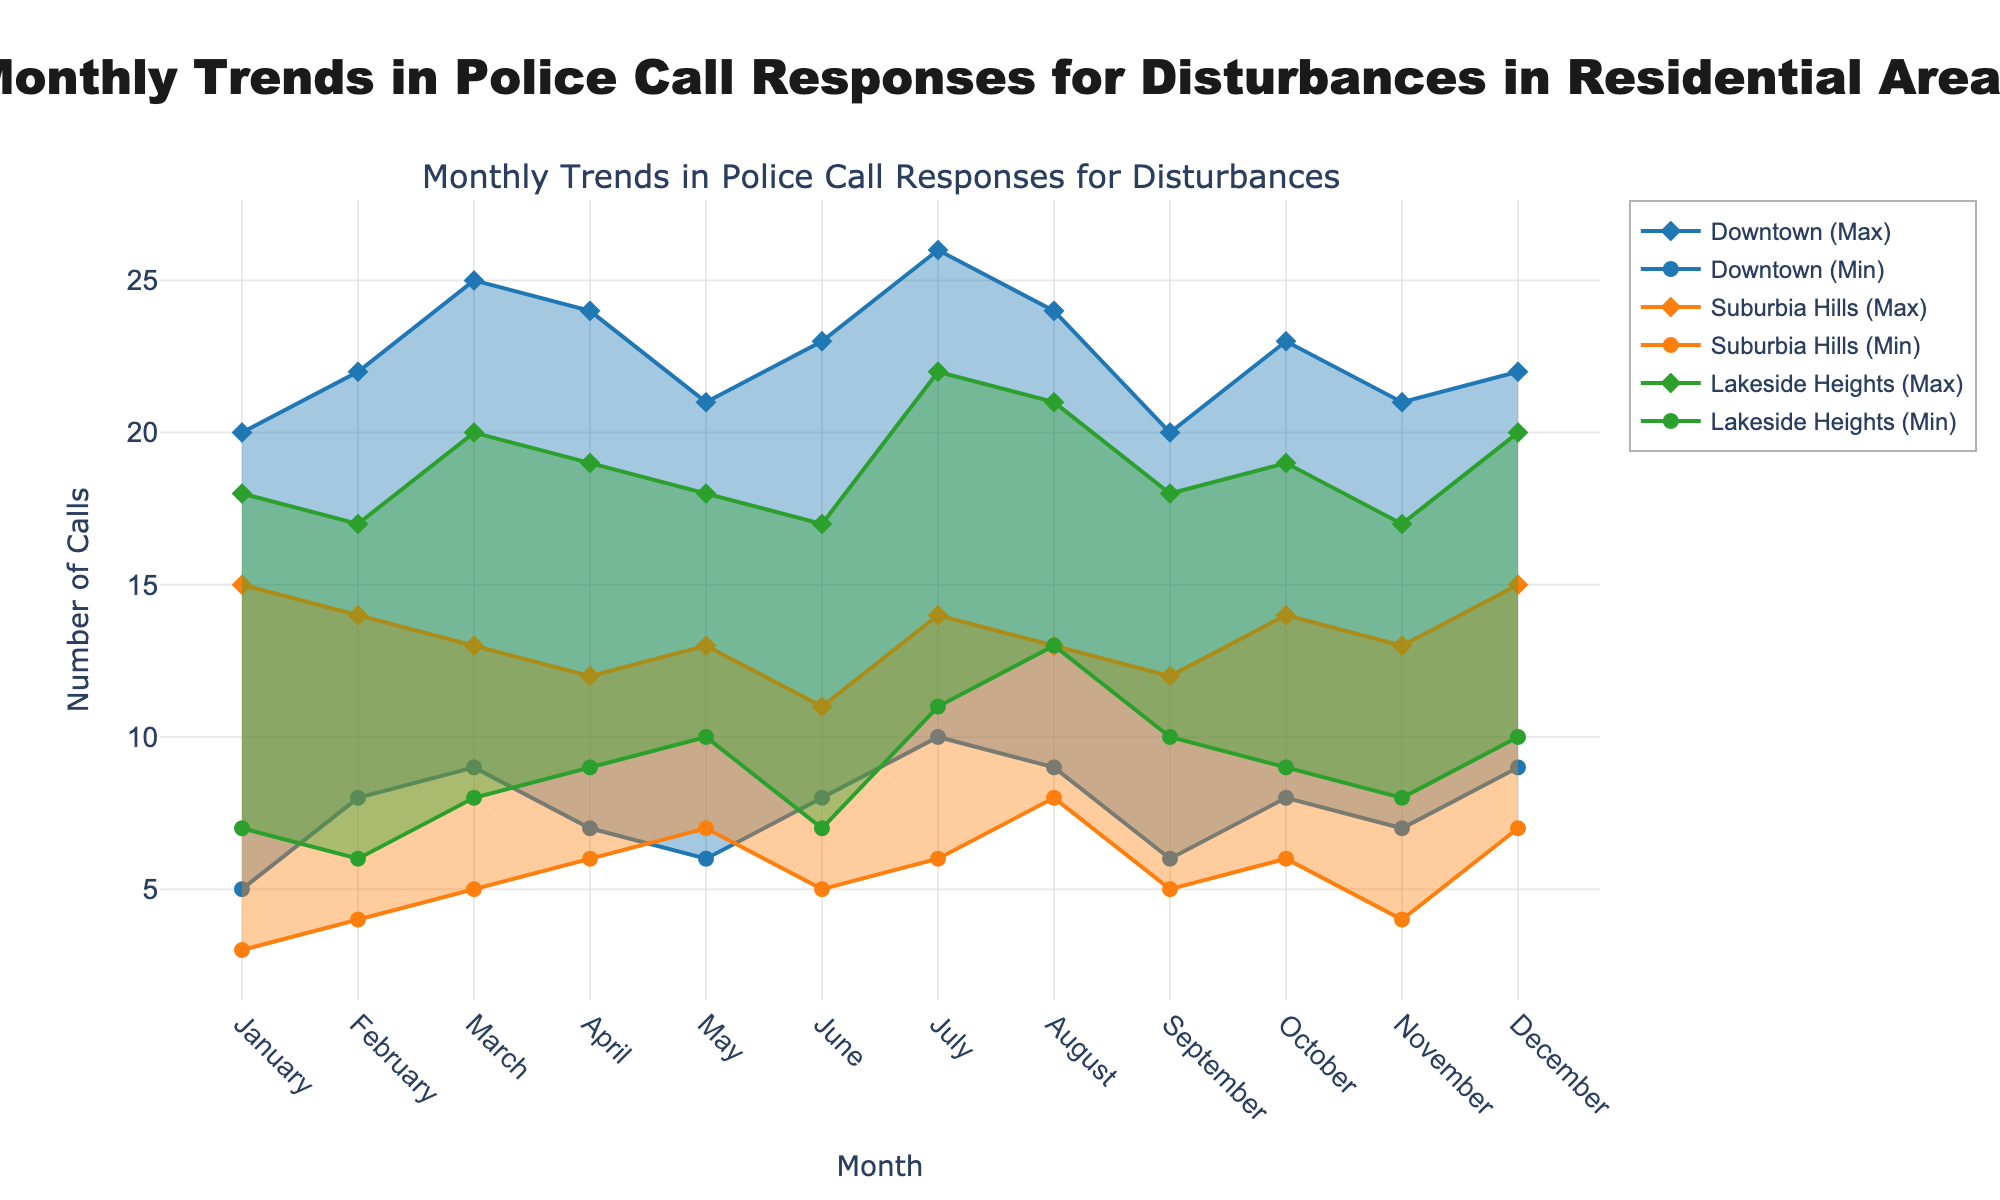What is the title of the plot? The title of the plot is displayed prominently at the top and reads "Monthly Trends in Police Call Responses for Disturbances in Residential Areas."
Answer: Monthly Trends in Police Call Responses for Disturbances in Residential Areas Which neighborhood had the highest maximum number of calls in July? To find out which neighborhood had the highest maximum number of calls in July, check the data points for all neighborhoods in the July section. Downtown has a maximum of 26 calls, Suburbia Hills has a maximum of 14 calls, and Lakeside Heights has a maximum of 22 calls. The highest value is for Downtown.
Answer: Downtown How do the minimum number of calls in January compare between Downtown and Suburbia Hills? Look at the January data for the minimum number of calls for both Downtown and Suburbia Hills. Downtown has a minimum of 5 calls whereas Suburbia Hills has a minimum of 3 calls. Hence, Downtown had 2 more minimum calls than Suburbia Hills.
Answer: Downtown had 2 more calls In which month did Lakeside Heights have the same minimum and maximum number of calls? Check the plot for any months where the minimum and maximum values are the same for Lakeside Heights. This occurs when there's no shaded area for that particular month, but all months show a range, meaning the minimum and maximum are different.
Answer: None What is the average of maximum calls in Downtown from January to March? Add the maximum number of calls from January to March for Downtown: 20 (January) + 22 (February) + 25 (March) = 67. The number of months is 3. The average is 67/3.
Answer: 22.33 Which neighborhood shows the most significant variation in call responses in August? Identify the differences between minimum and maximum call numbers for each neighborhood in August. Downtown: 24 - 9 = 15, Suburbia Hills: 13 - 8 = 5, Lakeside Heights: 21 - 13 = 8. The most significant variation is in Downtown.
Answer: Downtown Over which months did Suburbia Hills experience a consistent decline in the maximum number of calls? Analyze the maximum call numbers for Suburbia Hills month-wise and identify the months where there is a consistent decrease. Notably, from May with 13 calls to June with 11 shows a decline. But a consistent decline over several months is not present.
Answer: None How many months recorded at least 20 maximum calls for Downtown? Check the data for Downtown and count the number of months where the maximum number of calls is 20 or higher: January (20), February (22), March (25), April (24), June (23), July (26), August (24), October (23), and December (22). Summing these, we get 9 months.
Answer: 9 What is the combined range of calls for Lakeside Heights in November and December? Calculate the range (maximum - minimum) separately for November and December for Lakeside Heights and sum them up. November: 17 - 8 = 9, December: 20 - 10 = 10. Hence, the combined range is 9 + 10.
Answer: 19 Which neighborhood showed the least variability in May? Compare the ranges (maximum - minimum) of calls for all neighborhoods in May. Downtown: 21 - 6 = 15, Suburbia Hills: 13 - 7 = 6, Lakeside Heights: 18 - 10 = 8. The least variability is shown by Suburbia Hills.
Answer: Suburbia Hills 